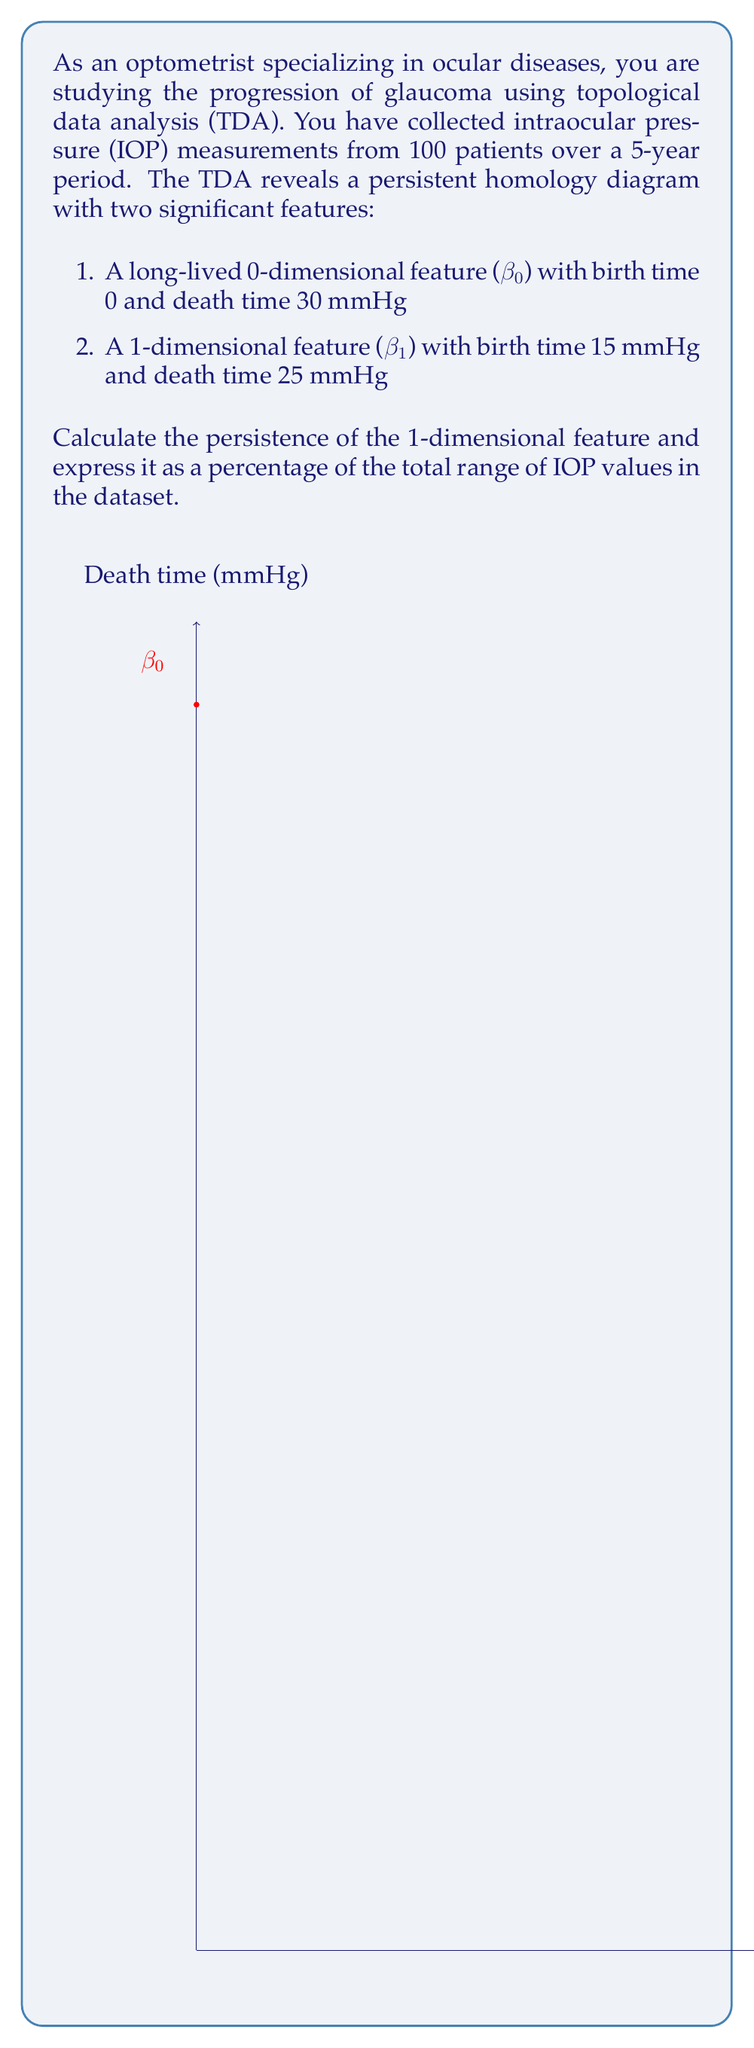Can you answer this question? To solve this problem, we'll follow these steps:

1. Identify the persistence of the 1-dimensional feature (β₁):
   Birth time = 15 mmHg
   Death time = 25 mmHg
   Persistence = Death time - Birth time
   $$ \text{Persistence} = 25 - 15 = 10 \text{ mmHg} $$

2. Determine the total range of IOP values:
   Minimum value = 0 mmHg (birth time of β₀)
   Maximum value = 30 mmHg (death time of β₀)
   Total range = Maximum - Minimum
   $$ \text{Total range} = 30 - 0 = 30 \text{ mmHg} $$

3. Calculate the persistence as a percentage of the total range:
   $$ \text{Persistence percentage} = \frac{\text{Persistence}}{\text{Total range}} \times 100\% $$
   $$ = \frac{10 \text{ mmHg}}{30 \text{ mmHg}} \times 100\% $$
   $$ = \frac{1}{3} \times 100\% $$
   $$ = 33.33\% $$

The persistence of the 1-dimensional feature (β₁) is 10 mmHg, which represents 33.33% of the total range of IOP values in the dataset.
Answer: 33.33% 